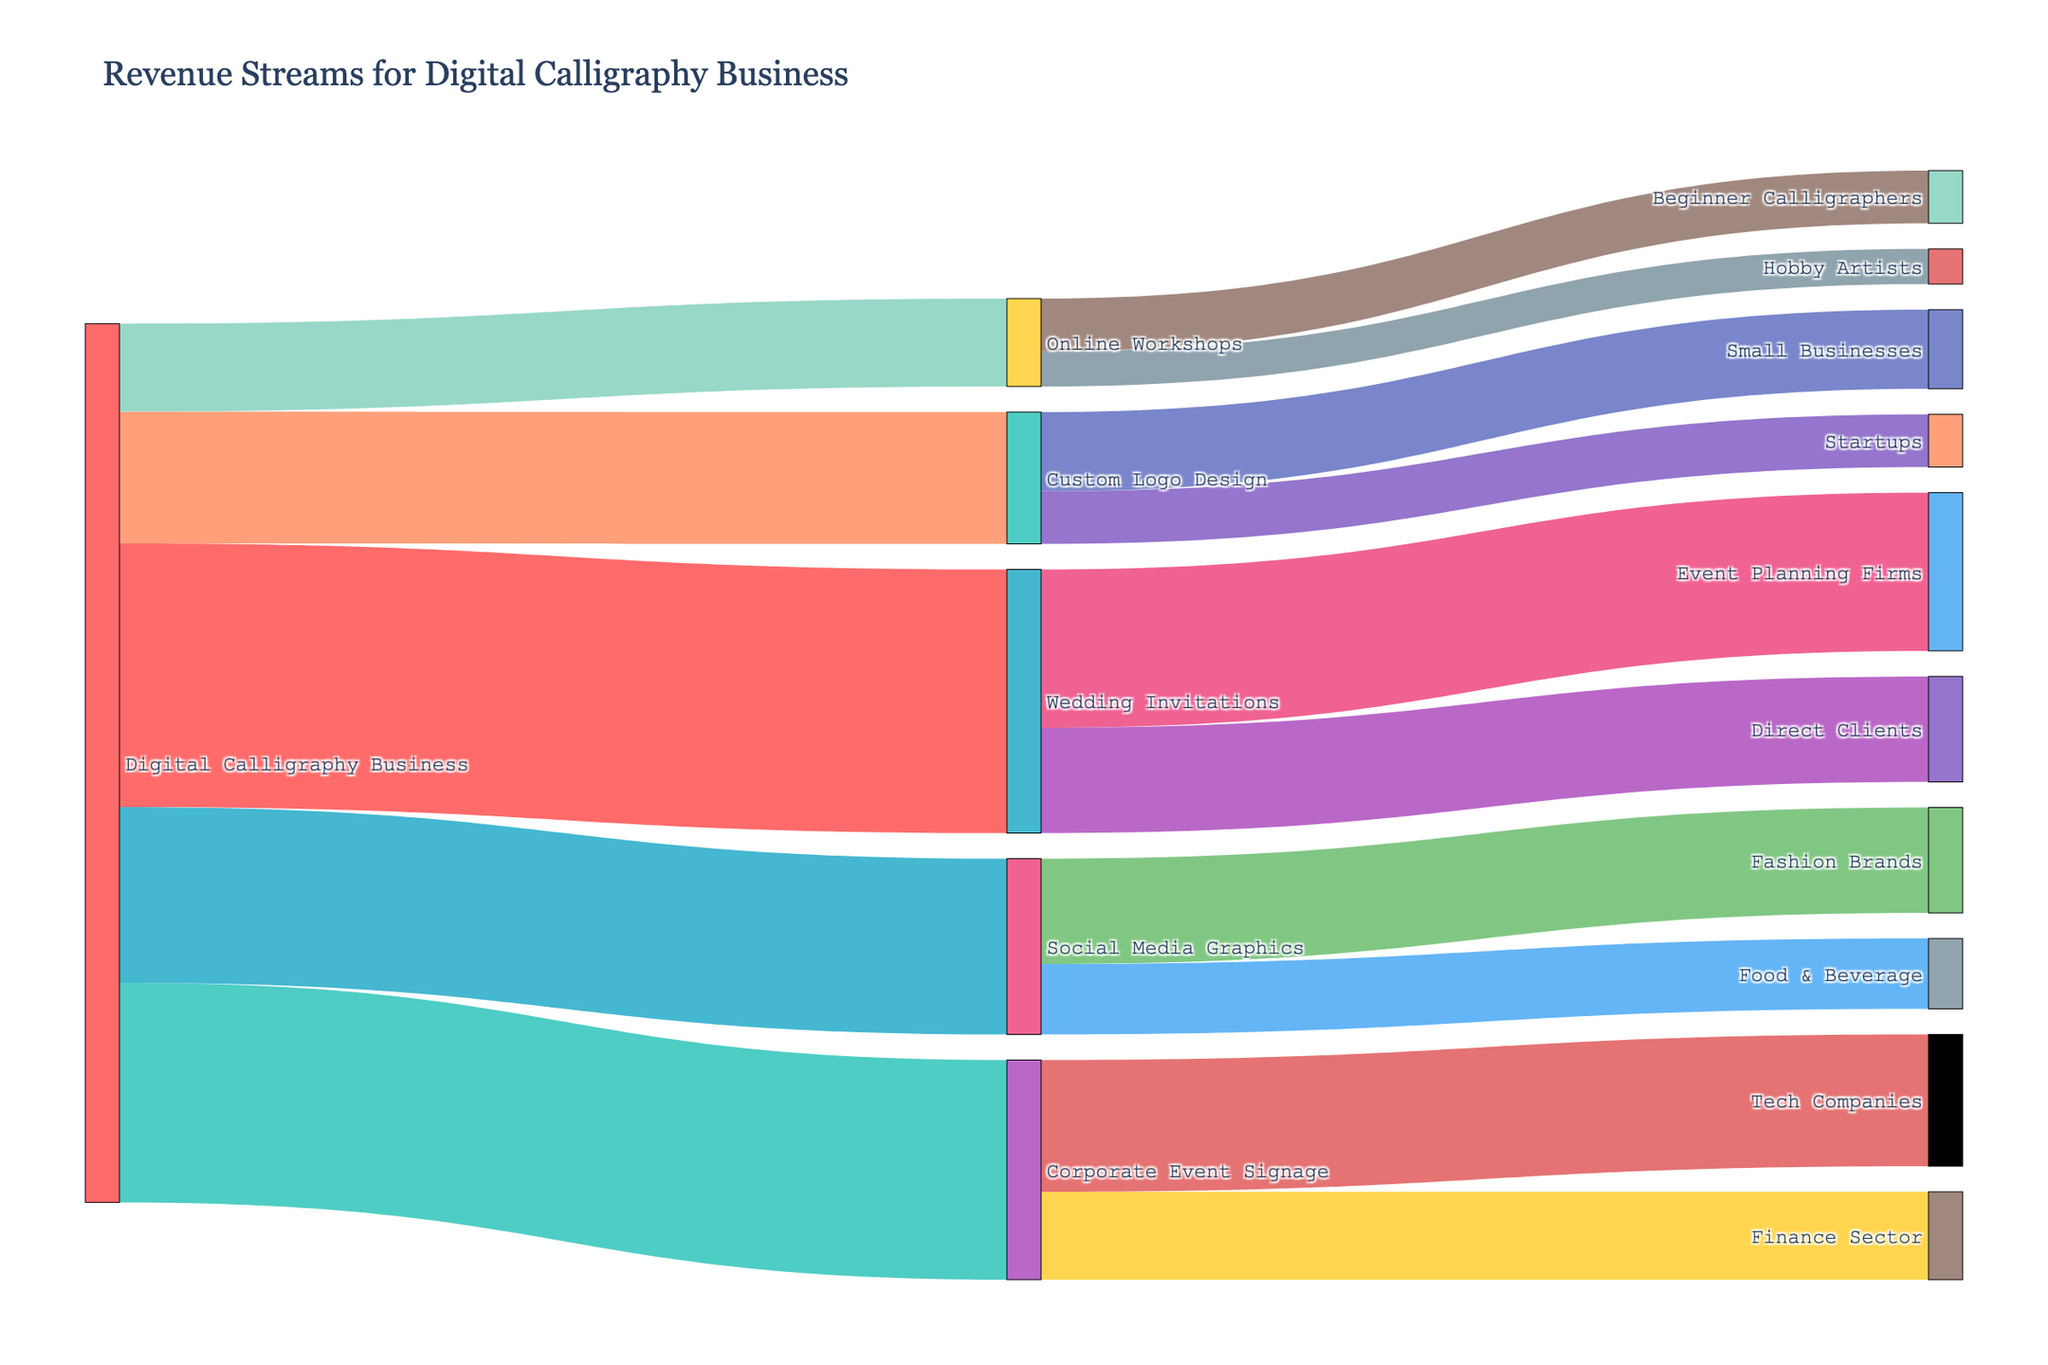What is the total revenue from Wedding Invitations? To find the total revenue from Wedding Invitations, sum up the values linked from 'Wedding Invitations' to the different client industries. These values are 18000 (Event Planning Firms) and 12000 (Direct Clients). Adding these gives 18000 + 12000 = 30000.
Answer: 30000 Which service generates the highest revenue? To determine which service generates the highest revenue, look at the values linked directly from the 'Digital Calligraphy Business' to each service type. The values are 30000, 25000, 20000, 15000, and 10000. The highest value is 30000, which corresponds to Wedding Invitations.
Answer: Wedding Invitations How much more revenue do Tech Companies bring in compared to Finance Sector for Corporate Event Signage? Identify the revenue from Tech Companies and Finance Sector linked to Corporate Event Signage. These values are 15000 (Tech Companies) and 10000 (Finance Sector). The difference is 15000 - 10000 = 5000.
Answer: 5000 What is the combined revenue generated from Social Media Graphics? Add the revenue from Fashion Brands and Food & Beverage, which are linked to Social Media Graphics. The values are 12000 and 8000. Adding these gives 12000 + 8000 = 20000.
Answer: 20000 What percentage of the total revenue does Custom Logo Design contribute? First, calculate the total revenue from all services: 30000 + 25000 + 20000 + 15000 + 10000 = 100000. Custom Logo Design contributes 15000. The percentage is (15000/100000) * 100 = 15%.
Answer: 15% Which client industry contributes the least revenue to Online Workshops? Check the revenue from each client industry linked to Online Workshops. The values are 6000 (Beginner Calligraphers) and 4000 (Hobby Artists). The smallest value is 4000, which corresponds to Hobby Artists.
Answer: Hobby Artists Is the total revenue from Corporate Event Signage greater than the revenue from Custom Logo Design and Online Workshops combined? Total revenue from Corporate Event Signage is 25000. Combined revenue from Custom Logo Design and Online Workshops is 15000 + 10000 = 25000. 25000 is equal to 25000.
Answer: No What is the average revenue per client industry for Wedding Invitations? Add the revenue from Event Planning Firms (18000) and Direct Clients (12000) linked to Wedding Invitations, resulting in 30000. There are 2 client industries. The average is 30000 / 2 = 15000.
Answer: 15000 